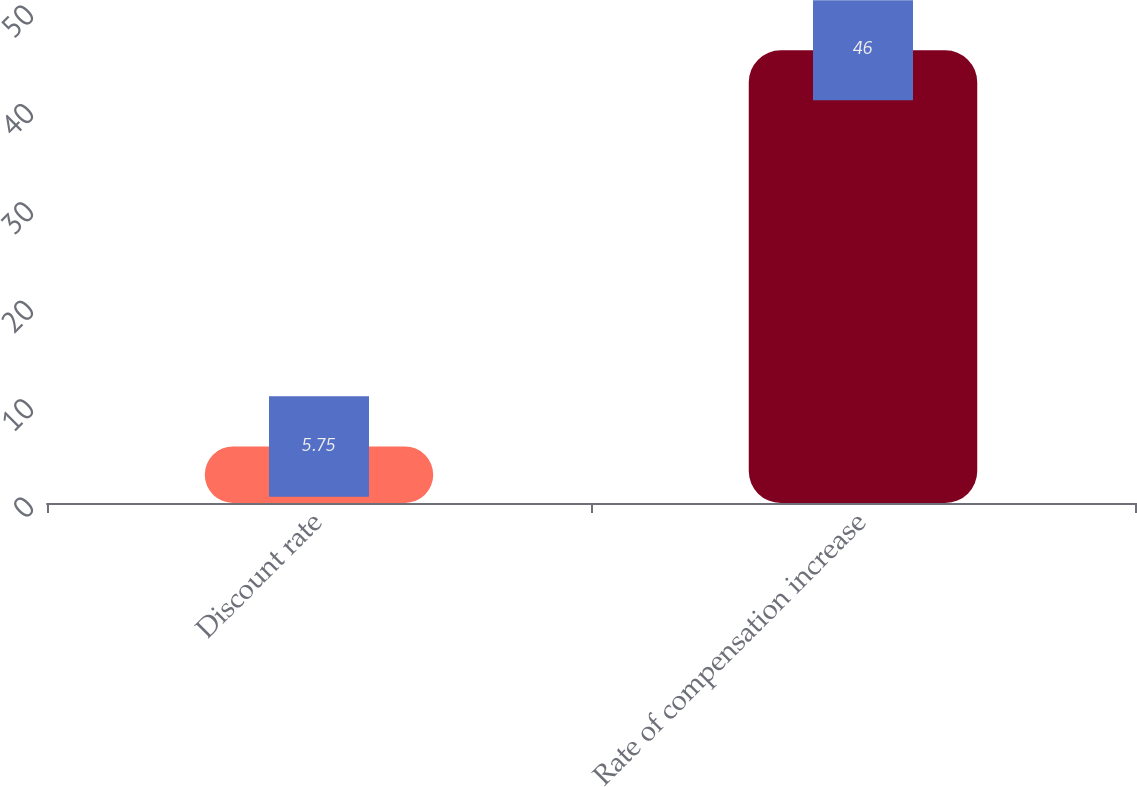<chart> <loc_0><loc_0><loc_500><loc_500><bar_chart><fcel>Discount rate<fcel>Rate of compensation increase<nl><fcel>5.75<fcel>46<nl></chart> 